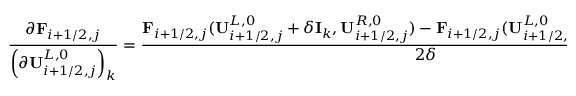Convert formula to latex. <formula><loc_0><loc_0><loc_500><loc_500>\frac { \partial F _ { i + 1 / 2 , j } } { \left ( \partial U _ { i + 1 / 2 , j } ^ { L , 0 } \right ) _ { k } } = \frac { F _ { i + 1 / 2 , j } ( U _ { i + 1 / 2 , j } ^ { L , 0 } + \delta I _ { k } , U _ { i + 1 / 2 , j } ^ { R , 0 } ) - F _ { i + 1 / 2 , j } ( U _ { i + 1 / 2 , j } ^ { L , 0 } - \delta I _ { k } , U _ { i + 1 / 2 , j } ^ { R , 0 } ) } { 2 \delta } ,</formula> 